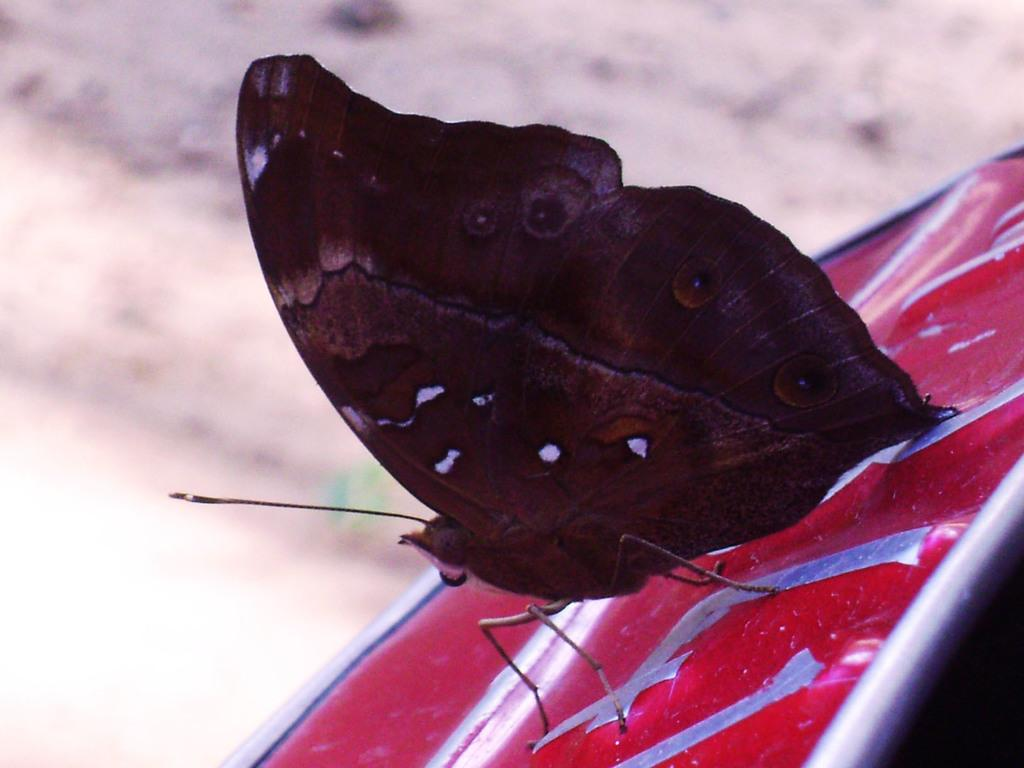What is the main subject of the image? The main subject of the image is a butterfly. What is the butterfly resting on? The butterfly is on a red color stand. What type of flesh can be seen on the butterfly in the image? There is no flesh visible on the butterfly in the image, as butterflies are insects with exoskeletons. 